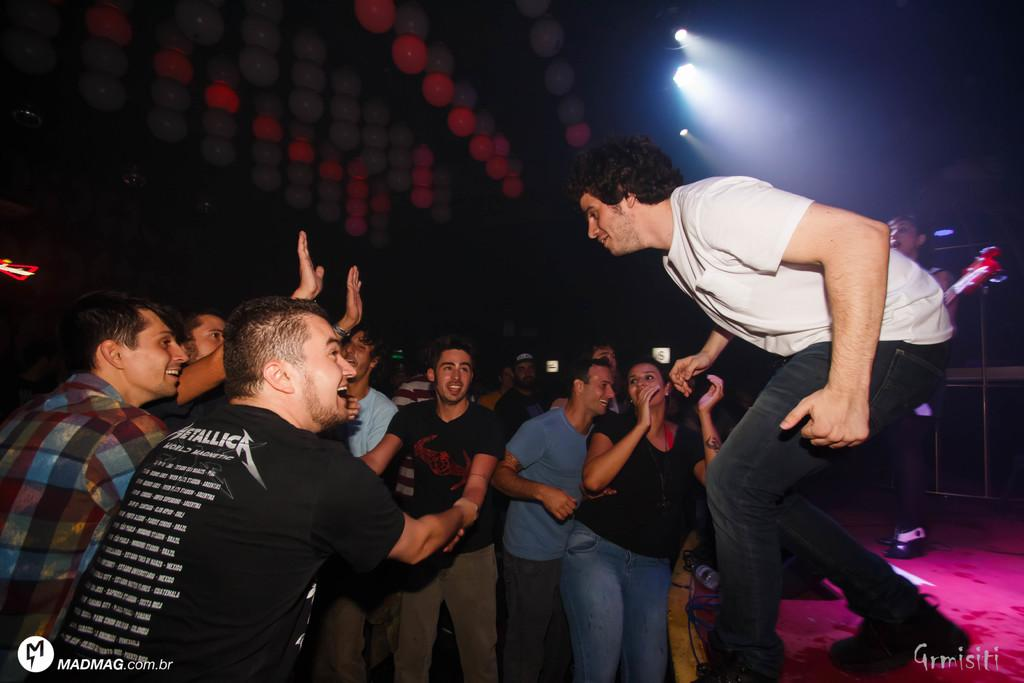What types of people are present in the image? There are men and women standing in the image. Where are the people standing? They are standing on the floor. Can you describe any objects or items the people are holding? One of them is holding a musical instrument. What can be seen in the background of the image? There are electric lights in the background of the image. What type of cream is being used to commit a crime in the image? There is no cream or crime present in the image; it features men and women standing on the floor, with one holding a musical instrument, and electric lights in the background. 